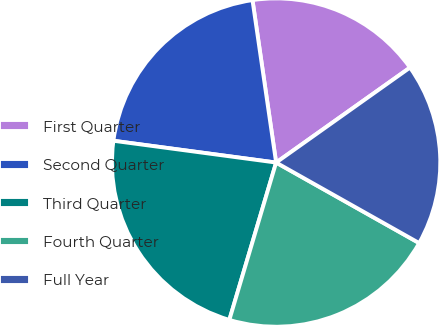<chart> <loc_0><loc_0><loc_500><loc_500><pie_chart><fcel>First Quarter<fcel>Second Quarter<fcel>Third Quarter<fcel>Fourth Quarter<fcel>Full Year<nl><fcel>17.48%<fcel>20.58%<fcel>22.52%<fcel>21.44%<fcel>17.98%<nl></chart> 